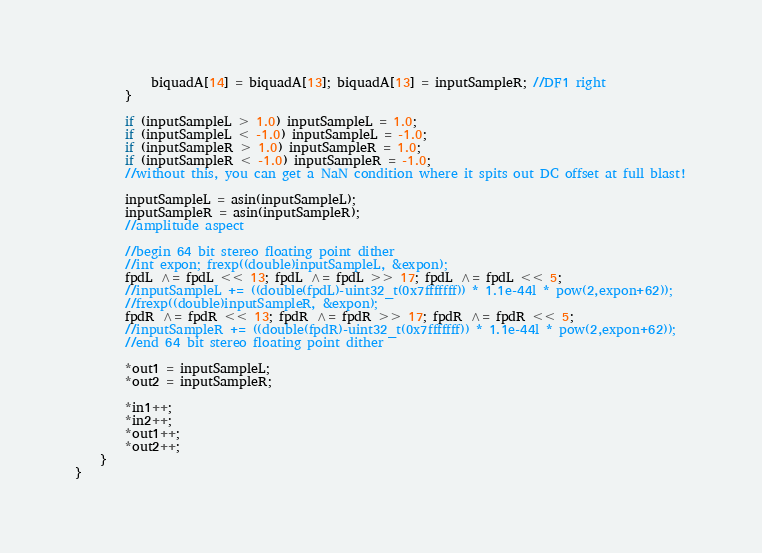Convert code to text. <code><loc_0><loc_0><loc_500><loc_500><_C++_>			biquadA[14] = biquadA[13]; biquadA[13] = inputSampleR; //DF1 right
		}		
		
		if (inputSampleL > 1.0) inputSampleL = 1.0;
		if (inputSampleL < -1.0) inputSampleL = -1.0;
		if (inputSampleR > 1.0) inputSampleR = 1.0;
		if (inputSampleR < -1.0) inputSampleR = -1.0;
		//without this, you can get a NaN condition where it spits out DC offset at full blast!
		
		inputSampleL = asin(inputSampleL);
		inputSampleR = asin(inputSampleR);
		//amplitude aspect
		
		//begin 64 bit stereo floating point dither
		//int expon; frexp((double)inputSampleL, &expon);
		fpdL ^= fpdL << 13; fpdL ^= fpdL >> 17; fpdL ^= fpdL << 5;
		//inputSampleL += ((double(fpdL)-uint32_t(0x7fffffff)) * 1.1e-44l * pow(2,expon+62));
		//frexp((double)inputSampleR, &expon);
		fpdR ^= fpdR << 13; fpdR ^= fpdR >> 17; fpdR ^= fpdR << 5;
		//inputSampleR += ((double(fpdR)-uint32_t(0x7fffffff)) * 1.1e-44l * pow(2,expon+62));
		//end 64 bit stereo floating point dither
		
		*out1 = inputSampleL;
		*out2 = inputSampleR;

		*in1++;
		*in2++;
		*out1++;
		*out2++;
    }
}
</code> 